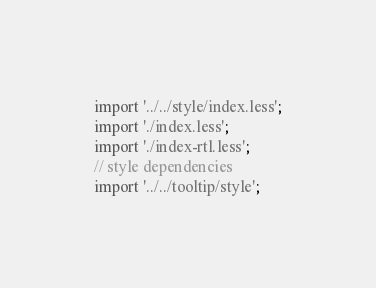Convert code to text. <code><loc_0><loc_0><loc_500><loc_500><_JavaScript_>import '../../style/index.less';
import './index.less';
import './index-rtl.less';
// style dependencies
import '../../tooltip/style';</code> 